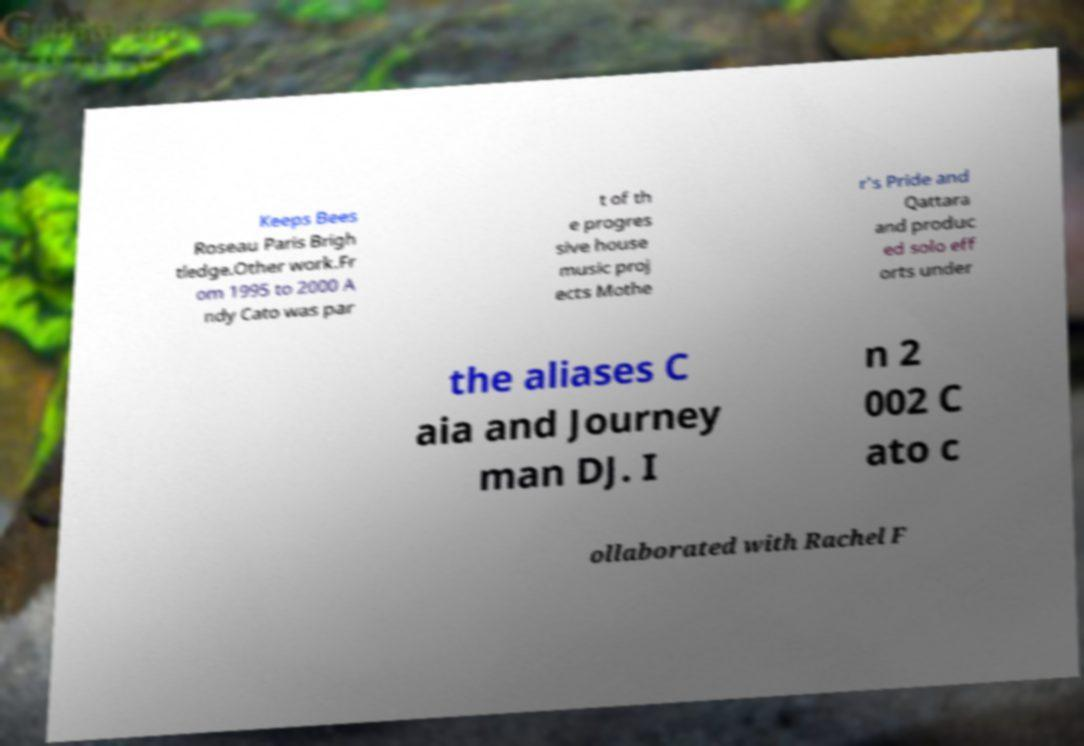Could you assist in decoding the text presented in this image and type it out clearly? Keeps Bees Roseau Paris Brigh tledge.Other work.Fr om 1995 to 2000 A ndy Cato was par t of th e progres sive house music proj ects Mothe r's Pride and Qattara and produc ed solo eff orts under the aliases C aia and Journey man DJ. I n 2 002 C ato c ollaborated with Rachel F 